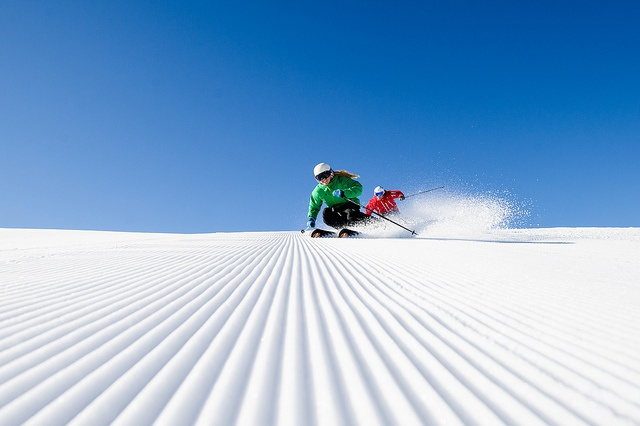Describe the objects in this image and their specific colors. I can see people in gray, black, darkgreen, and green tones, people in gray, brown, maroon, and darkgray tones, and skis in gray, black, and darkgray tones in this image. 